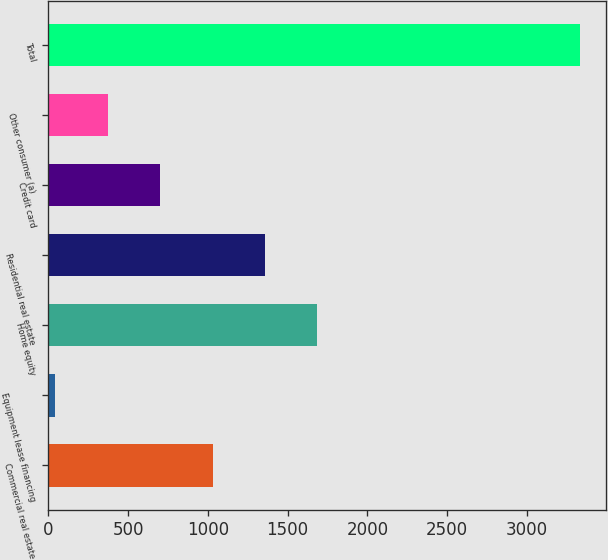Convert chart. <chart><loc_0><loc_0><loc_500><loc_500><bar_chart><fcel>Commercial real estate<fcel>Equipment lease financing<fcel>Home equity<fcel>Residential real estate<fcel>Credit card<fcel>Other consumer (a)<fcel>Total<nl><fcel>1030.1<fcel>44<fcel>1687.5<fcel>1358.8<fcel>701.4<fcel>372.7<fcel>3331<nl></chart> 